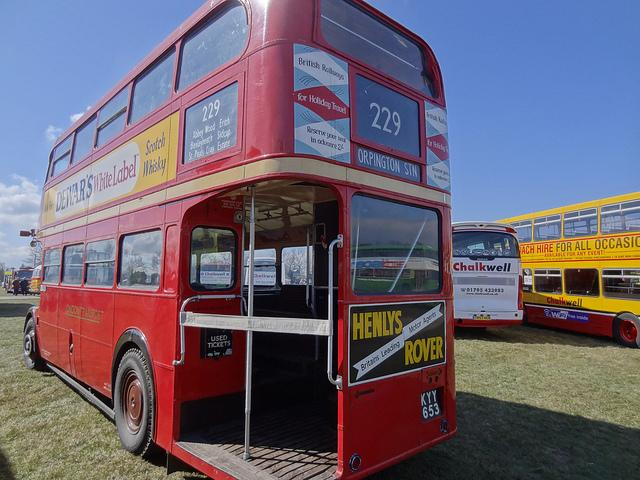What number is closest to the number at the top of the bus? 229 